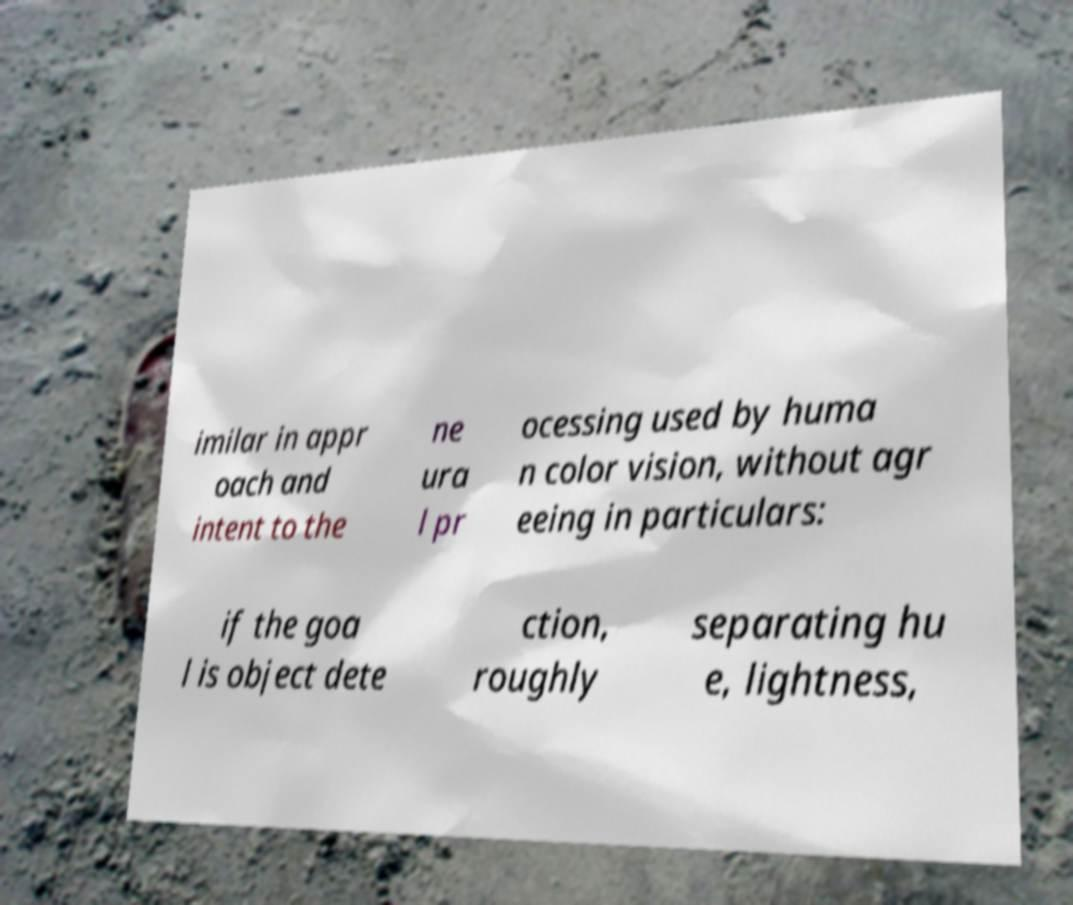There's text embedded in this image that I need extracted. Can you transcribe it verbatim? imilar in appr oach and intent to the ne ura l pr ocessing used by huma n color vision, without agr eeing in particulars: if the goa l is object dete ction, roughly separating hu e, lightness, 